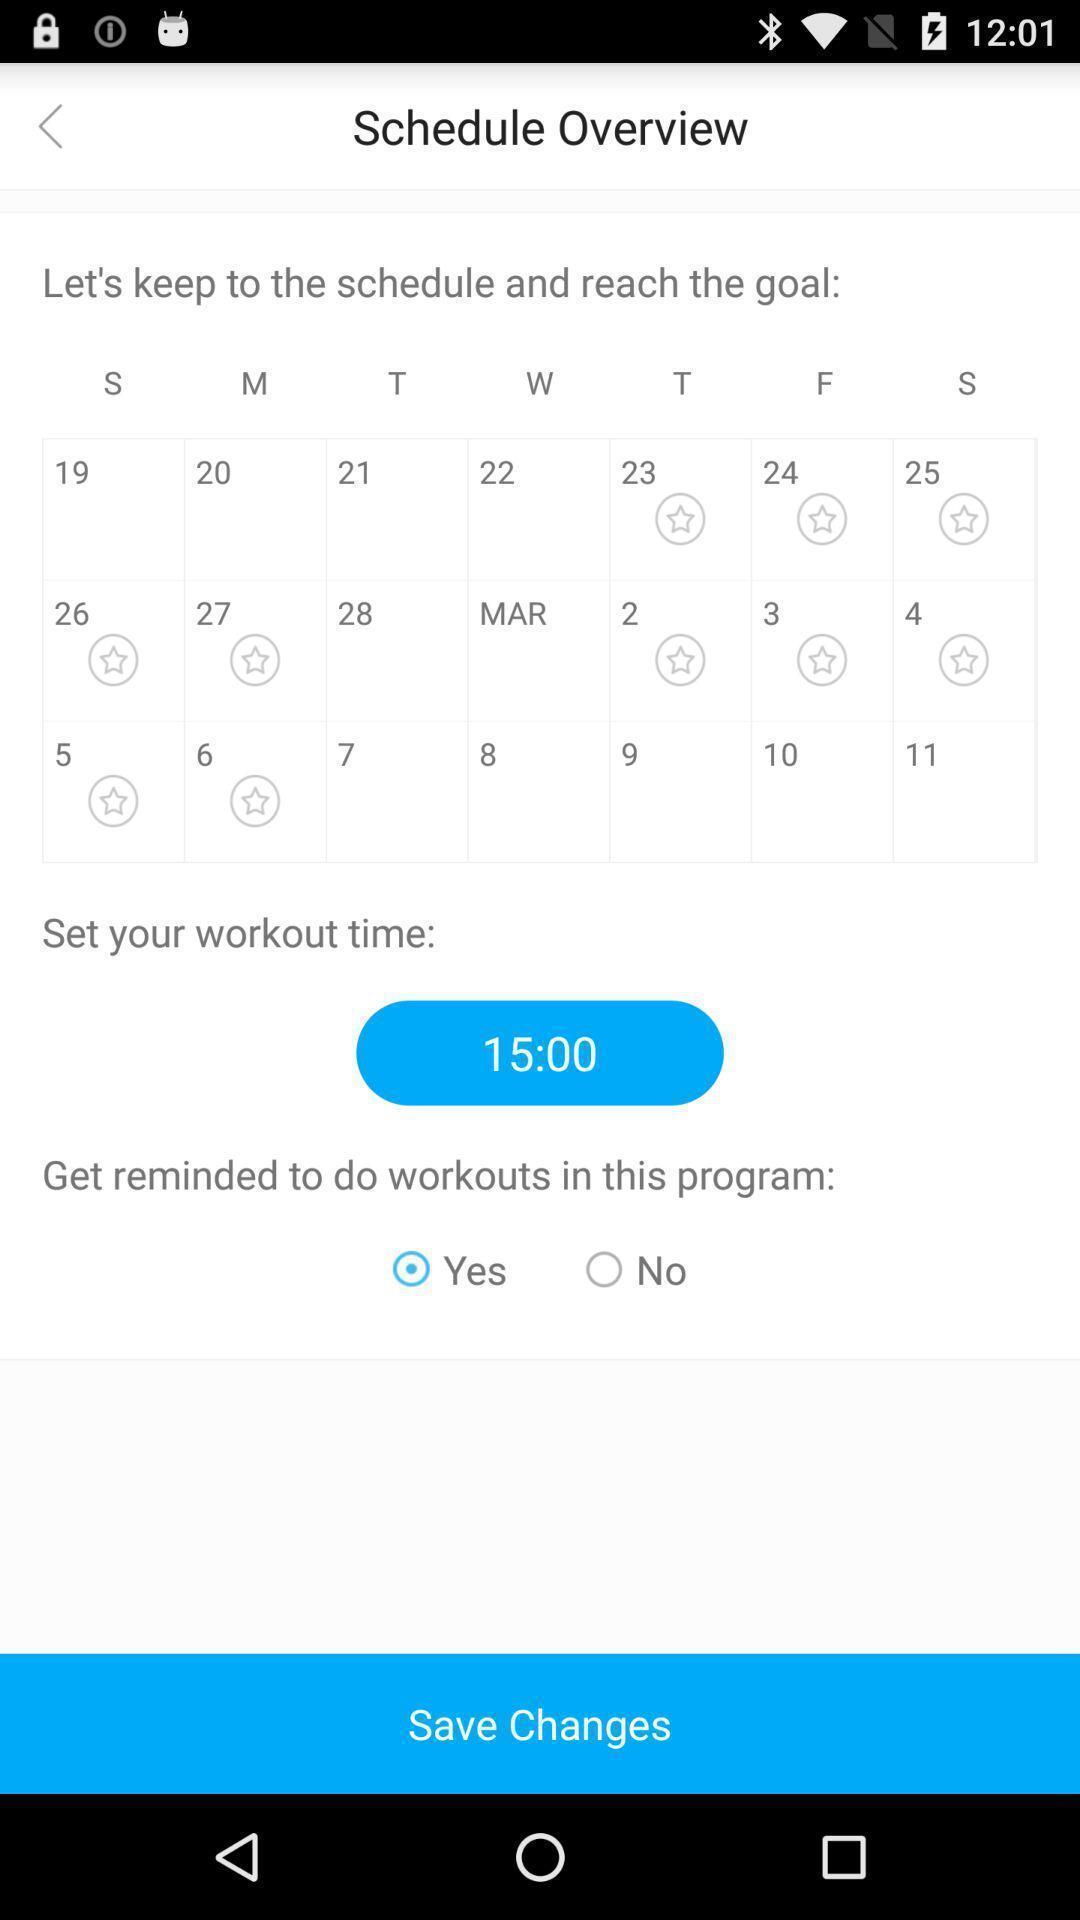Provide a detailed account of this screenshot. Schedule page of a workout app. 